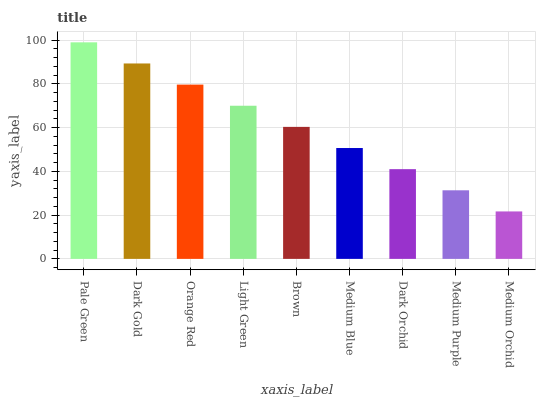Is Medium Orchid the minimum?
Answer yes or no. Yes. Is Pale Green the maximum?
Answer yes or no. Yes. Is Dark Gold the minimum?
Answer yes or no. No. Is Dark Gold the maximum?
Answer yes or no. No. Is Pale Green greater than Dark Gold?
Answer yes or no. Yes. Is Dark Gold less than Pale Green?
Answer yes or no. Yes. Is Dark Gold greater than Pale Green?
Answer yes or no. No. Is Pale Green less than Dark Gold?
Answer yes or no. No. Is Brown the high median?
Answer yes or no. Yes. Is Brown the low median?
Answer yes or no. Yes. Is Pale Green the high median?
Answer yes or no. No. Is Medium Purple the low median?
Answer yes or no. No. 